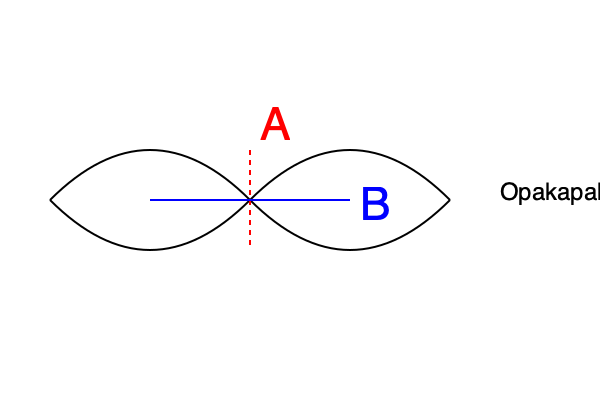When preparing an Opakapaka (Hawaiian Pink Snapper) for sashimi, which cutting pattern would yield the most optimal results in terms of texture and presentation? Refer to the diagram and explain your reasoning based on the fish's muscle structure. To determine the optimal cutting pattern for Opakapaka sashimi, we need to consider the fish's muscle structure and how it affects texture and presentation:

1. Fish muscle structure: 
   - Fish muscles are arranged in segments called myomeres, separated by sheets of connective tissue.
   - These myomeres form a zigzag pattern along the length of the fish.

2. Cutting options:
   - Line A (vertical): Cutting perpendicular to the spine
   - Line B (horizontal): Cutting parallel to the spine

3. Texture considerations:
   - Cutting along Line A would result in cross-sections of multiple myomeres.
   - This creates a more tender texture as it breaks up the muscle fibers.
   - Cutting along Line B would result in longer strips of individual myomeres.
   - This creates a firmer, more fibrous texture.

4. Presentation considerations:
   - Line A cuts produce uniform, circular slices that showcase the fish's color and marbling.
   - Line B cuts produce longer strips that can be arranged more creatively on the plate.

5. Opakapaka-specific factors:
   - Opakapaka has a delicate, slightly firm texture.
   - Its flesh is prized for its subtle sweet flavor and pink hue.

6. Optimal cutting pattern:
   - For Opakapaka sashimi, the optimal cutting pattern is along Line A (vertical cuts).
   - This cutting method:
     a) Enhances the fish's naturally delicate texture by breaking up muscle fibers.
     b) Creates visually appealing, uniform slices that showcase the fish's color.
     c) Allows for better absorption of soy sauce or other accompaniments.
     d) Provides a more pleasant mouthfeel when consumed.

Therefore, the vertical cutting pattern (Line A) is optimal for Opakapaka sashimi, balancing texture and presentation while highlighting the fish's unique characteristics.
Answer: Vertical cuts (perpendicular to the spine) 